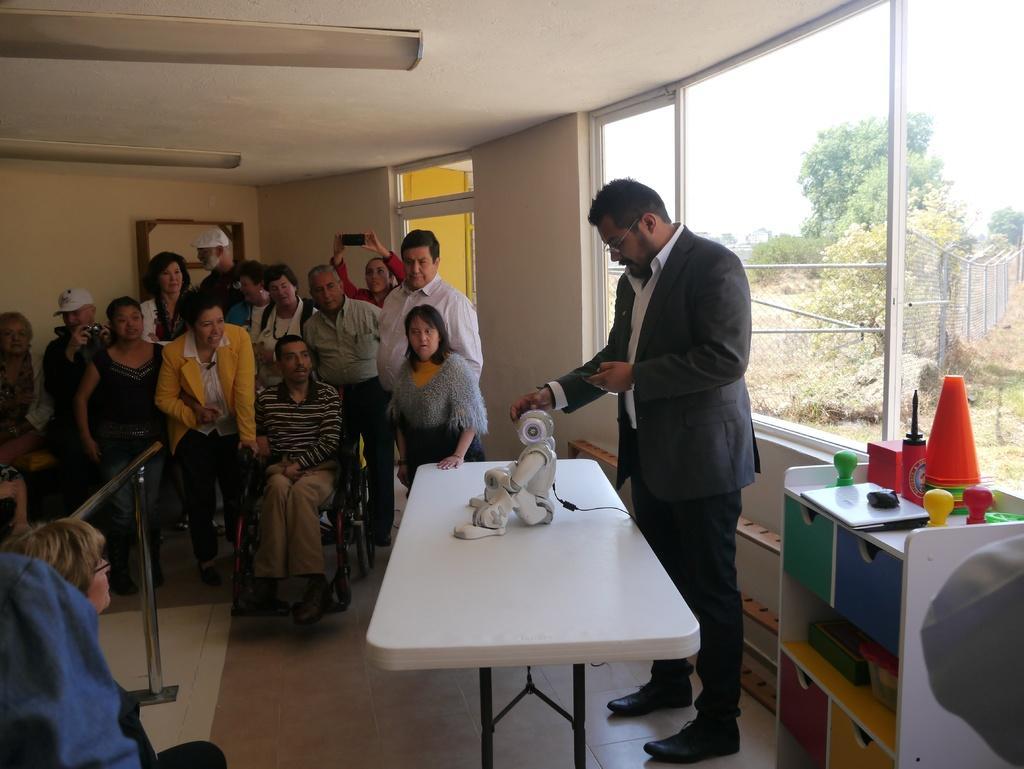In one or two sentences, can you explain what this image depicts? In this Image I see number of people in which few of them are sitting and rest of them are standing. I can also see a electronic device on this table and there is a rack over here in which there are few things in it. In the background I see the wall, windows, trees and the fence. 